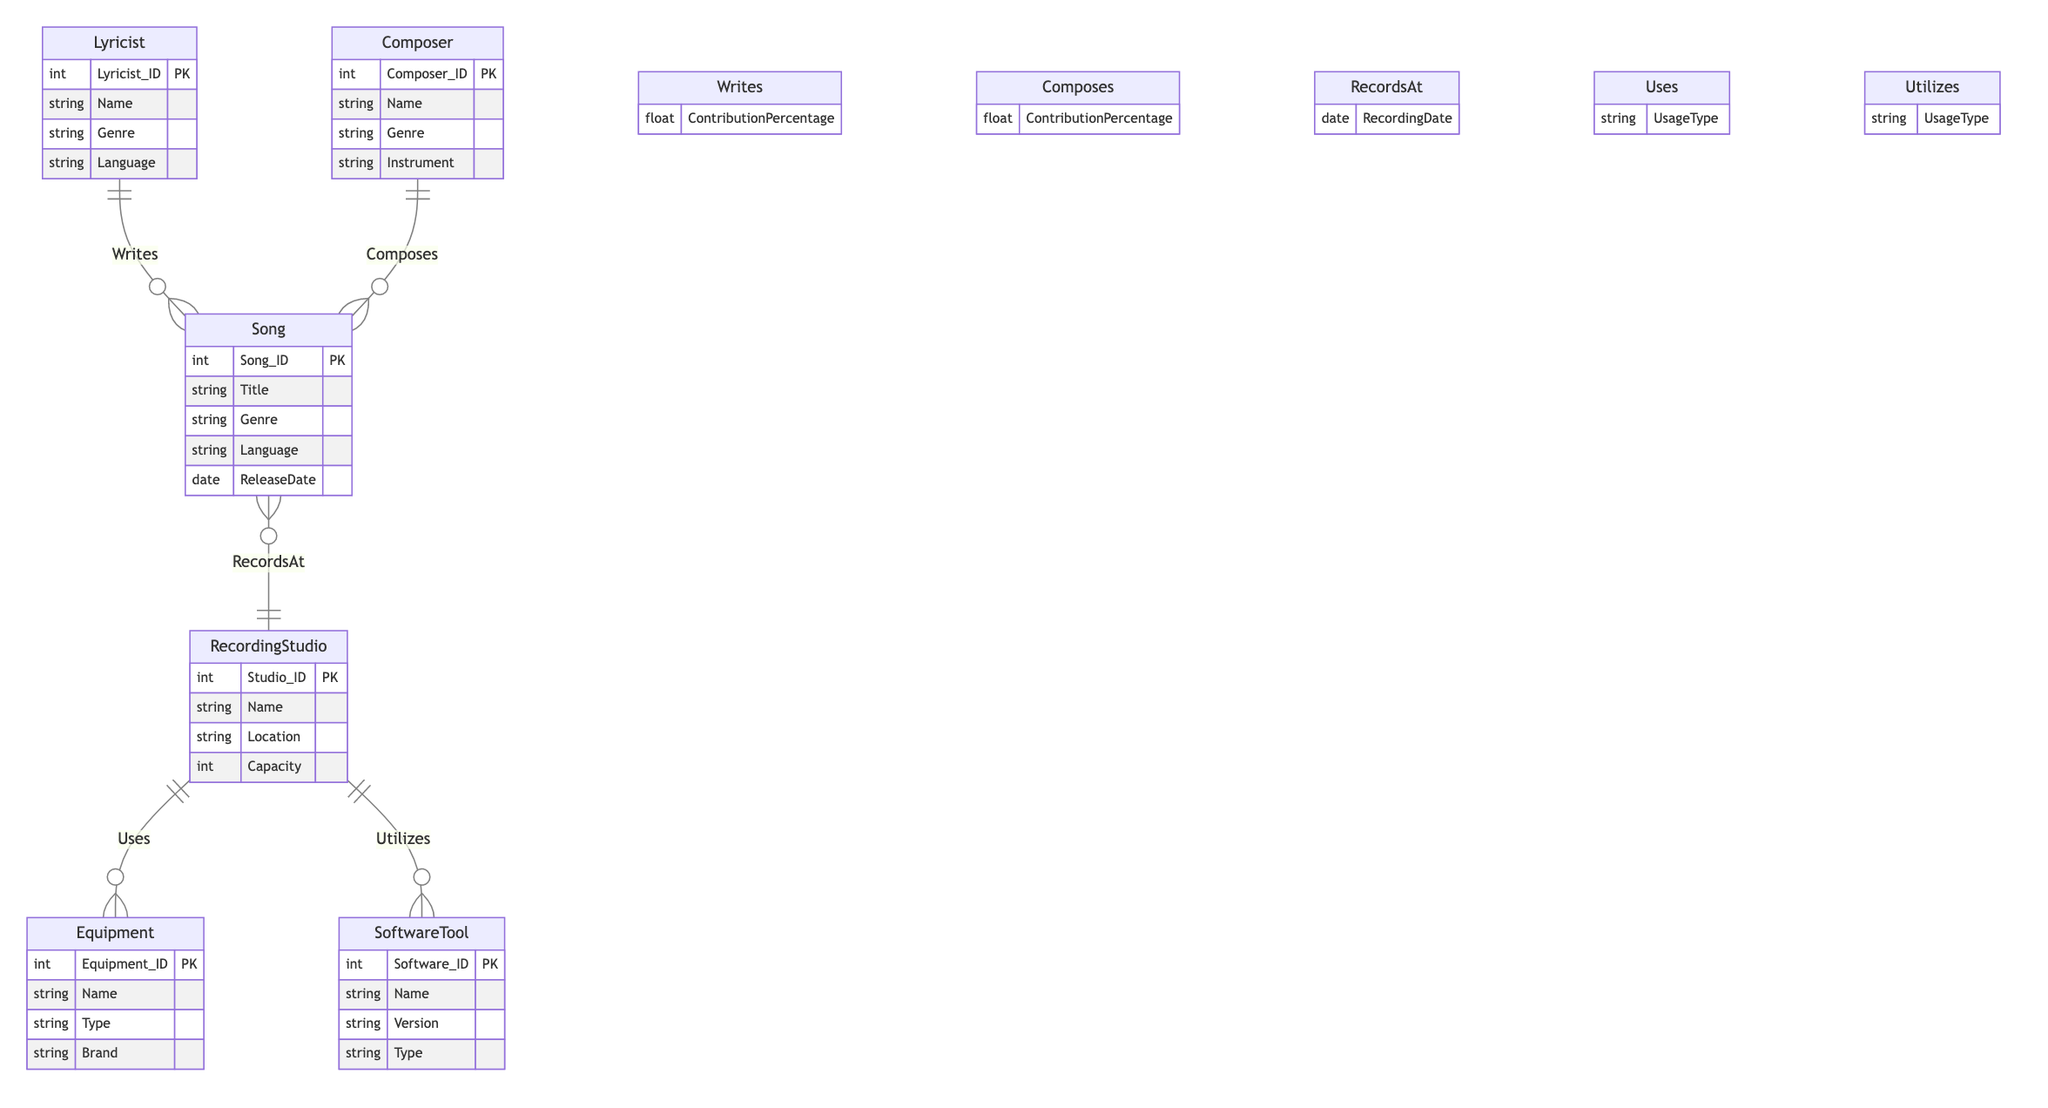What is the primary relationship between a Lyricist and a Song? The diagram shows a "Writes" relationship between Lyricist and Song, indicating that a Lyricist contributes to the creation of a Song.
Answer: Writes How many attributes does the Song entity have? The Song entity contains five attributes: Song_ID, Title, Genre, Language, and ReleaseDate.
Answer: Five What is the ContributionPercentage in the Writes relationship? The Writes relationship has an attribute called ContributionPercentage, which indicates the portion of the contribution made by the Lyricist towards the song's lyrics.
Answer: ContributionPercentage Which entity is related to RecordingStudio through the Uses relationship? The diagram indicates that Equipment is related to RecordingStudio through the Uses relationship, showing that studios utilize various types of equipment.
Answer: Equipment What type of relationship exists between Composer and Song? The diagram illustrates a "Composes" relationship, which signifies that a Composer is involved in the music composition of a Song.
Answer: Composes Which entity's attributes include Instrument? Looking at the Composer entity, it contains the attribute Instrument, which identifies the instruments the composer plays.
Answer: Composer How many entities are present in the diagram? The diagram lists six entities: Lyricist, Composer, Song, RecordingStudio, Equipment, and SoftwareTool.
Answer: Six What does the UsageType attribute signify in the Uses relationship? The UsageType attribute in the Uses relationship describes the specific nature of how Equipment is utilized in the RecordingStudio.
Answer: UsageType What is the connection between Song and RecordingStudio? The diagram establishes a "RecordsAt" relationship, indicating that a Song is recorded at a specific RecordingStudio.
Answer: RecordsAt 